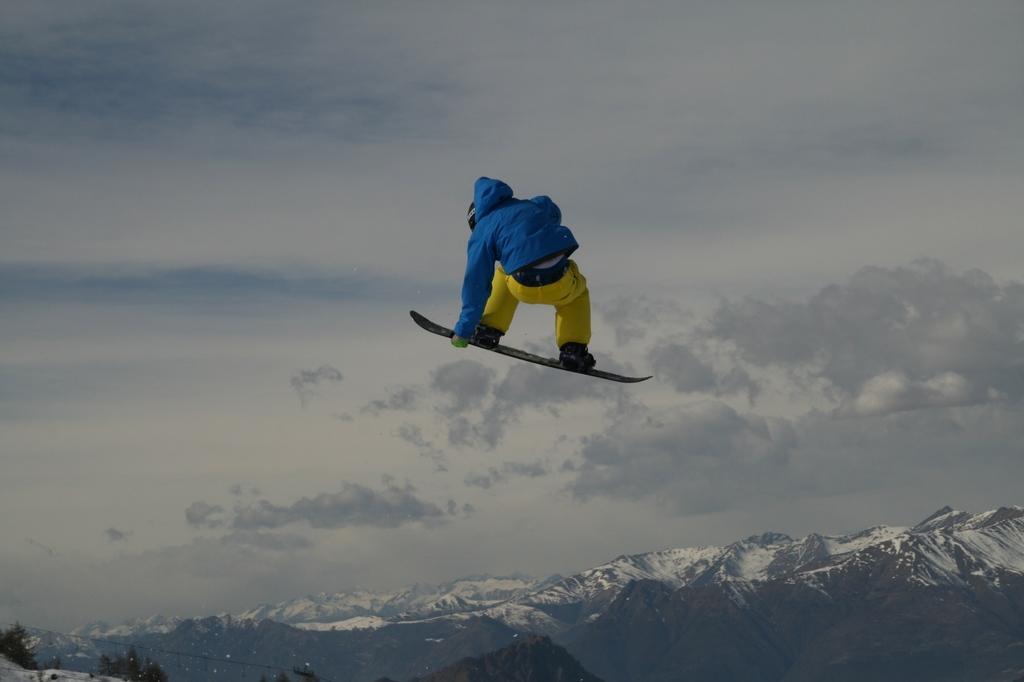Describe this image in one or two sentences. In this image I can see a person is on ski blades. In the background I can see mountains, trees and the sky. 